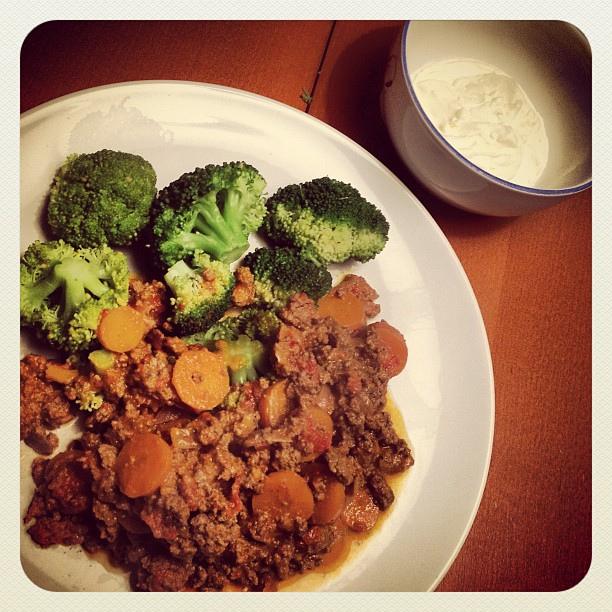What color is the main dish?
Give a very brief answer. Brown. What texture is the table made of?
Quick response, please. Wood. What kind of vegetable is on the plate?
Answer briefly. Broccoli. What color is the plate?
Quick response, please. White. 